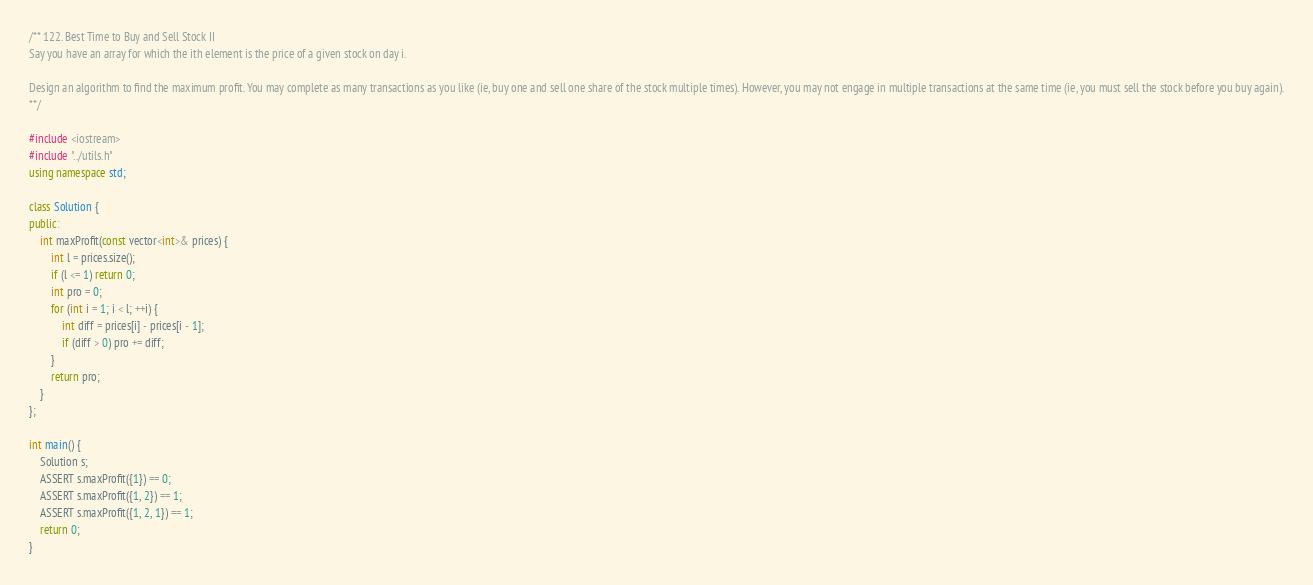<code> <loc_0><loc_0><loc_500><loc_500><_C++_>/** 122. Best Time to Buy and Sell Stock II
Say you have an array for which the ith element is the price of a given stock on day i.

Design an algorithm to find the maximum profit. You may complete as many transactions as you like (ie, buy one and sell one share of the stock multiple times). However, you may not engage in multiple transactions at the same time (ie, you must sell the stock before you buy again).
**/

#include <iostream>
#include "../utils.h"
using namespace std;

class Solution {
public:
    int maxProfit(const vector<int>& prices) {
        int l = prices.size();
        if (l <= 1) return 0;
        int pro = 0;
        for (int i = 1; i < l; ++i) {
            int diff = prices[i] - prices[i - 1];
            if (diff > 0) pro += diff;
        }
        return pro;
    }
};

int main() {
    Solution s;
    ASSERT s.maxProfit({1}) == 0;
    ASSERT s.maxProfit({1, 2}) == 1;
    ASSERT s.maxProfit({1, 2, 1}) == 1;
    return 0;
}
</code> 